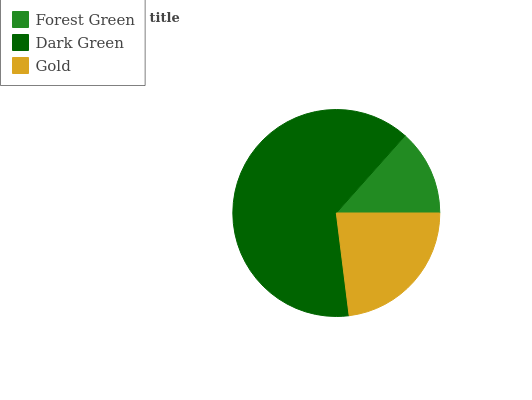Is Forest Green the minimum?
Answer yes or no. Yes. Is Dark Green the maximum?
Answer yes or no. Yes. Is Gold the minimum?
Answer yes or no. No. Is Gold the maximum?
Answer yes or no. No. Is Dark Green greater than Gold?
Answer yes or no. Yes. Is Gold less than Dark Green?
Answer yes or no. Yes. Is Gold greater than Dark Green?
Answer yes or no. No. Is Dark Green less than Gold?
Answer yes or no. No. Is Gold the high median?
Answer yes or no. Yes. Is Gold the low median?
Answer yes or no. Yes. Is Dark Green the high median?
Answer yes or no. No. Is Forest Green the low median?
Answer yes or no. No. 